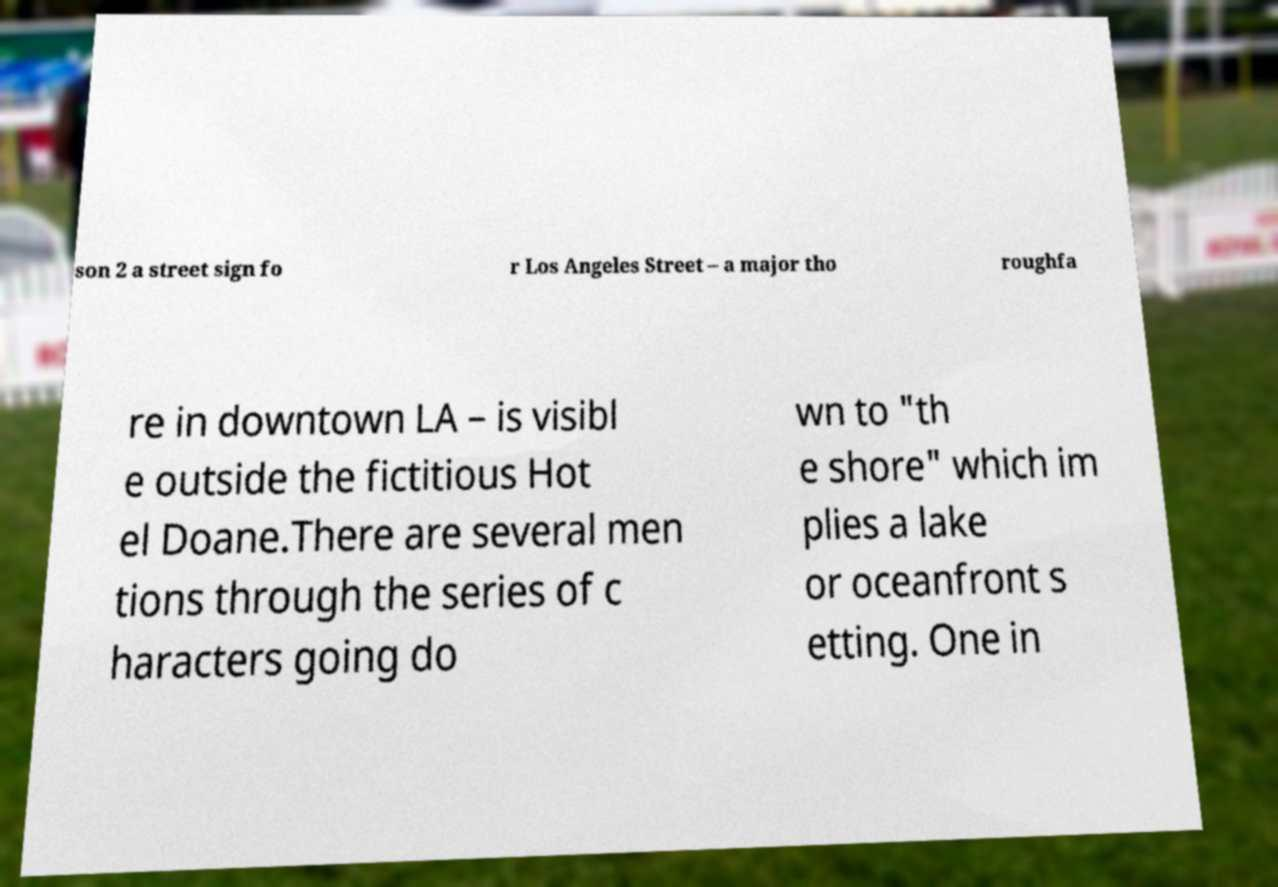Please identify and transcribe the text found in this image. son 2 a street sign fo r Los Angeles Street – a major tho roughfa re in downtown LA – is visibl e outside the fictitious Hot el Doane.There are several men tions through the series of c haracters going do wn to "th e shore" which im plies a lake or oceanfront s etting. One in 